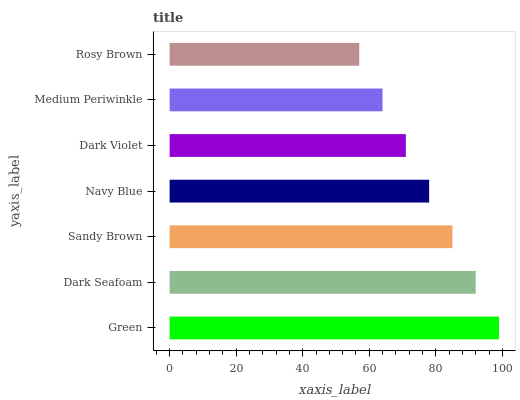Is Rosy Brown the minimum?
Answer yes or no. Yes. Is Green the maximum?
Answer yes or no. Yes. Is Dark Seafoam the minimum?
Answer yes or no. No. Is Dark Seafoam the maximum?
Answer yes or no. No. Is Green greater than Dark Seafoam?
Answer yes or no. Yes. Is Dark Seafoam less than Green?
Answer yes or no. Yes. Is Dark Seafoam greater than Green?
Answer yes or no. No. Is Green less than Dark Seafoam?
Answer yes or no. No. Is Navy Blue the high median?
Answer yes or no. Yes. Is Navy Blue the low median?
Answer yes or no. Yes. Is Sandy Brown the high median?
Answer yes or no. No. Is Medium Periwinkle the low median?
Answer yes or no. No. 